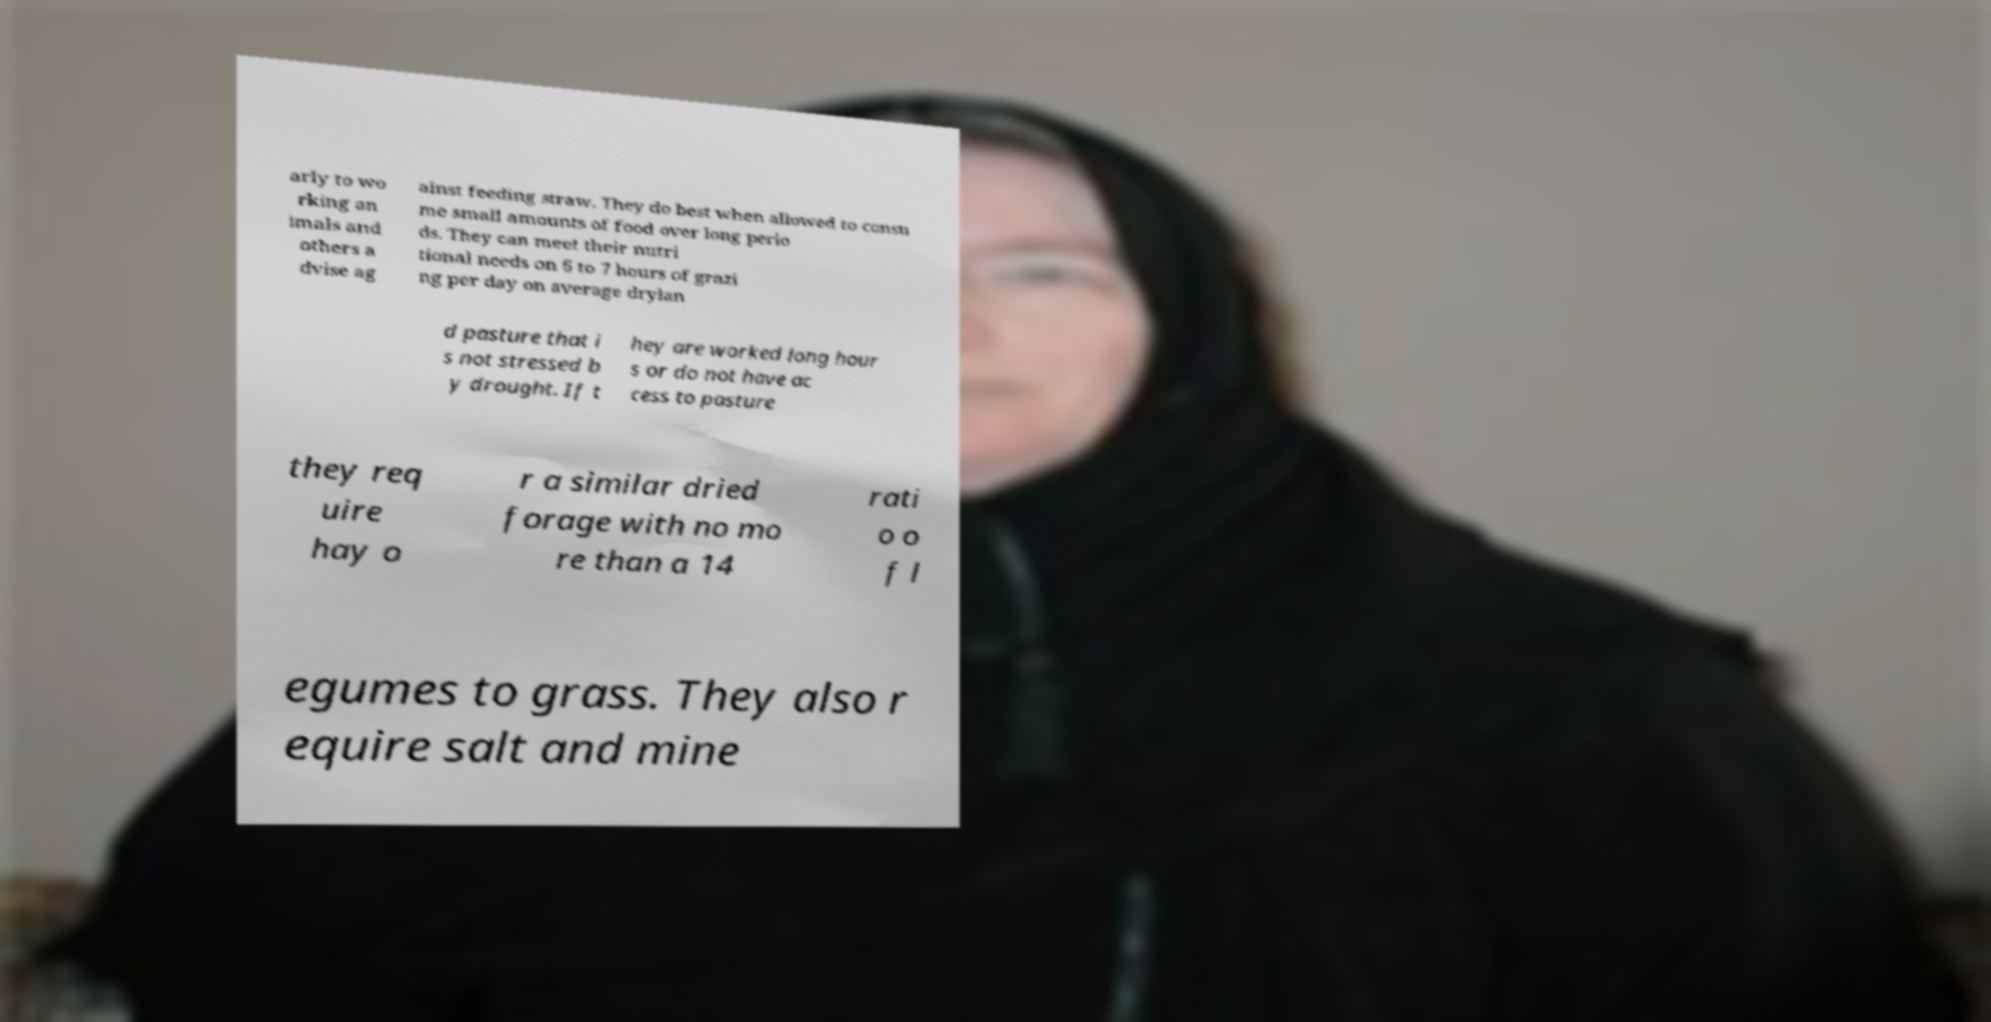Could you extract and type out the text from this image? arly to wo rking an imals and others a dvise ag ainst feeding straw. They do best when allowed to consu me small amounts of food over long perio ds. They can meet their nutri tional needs on 6 to 7 hours of grazi ng per day on average drylan d pasture that i s not stressed b y drought. If t hey are worked long hour s or do not have ac cess to pasture they req uire hay o r a similar dried forage with no mo re than a 14 rati o o f l egumes to grass. They also r equire salt and mine 